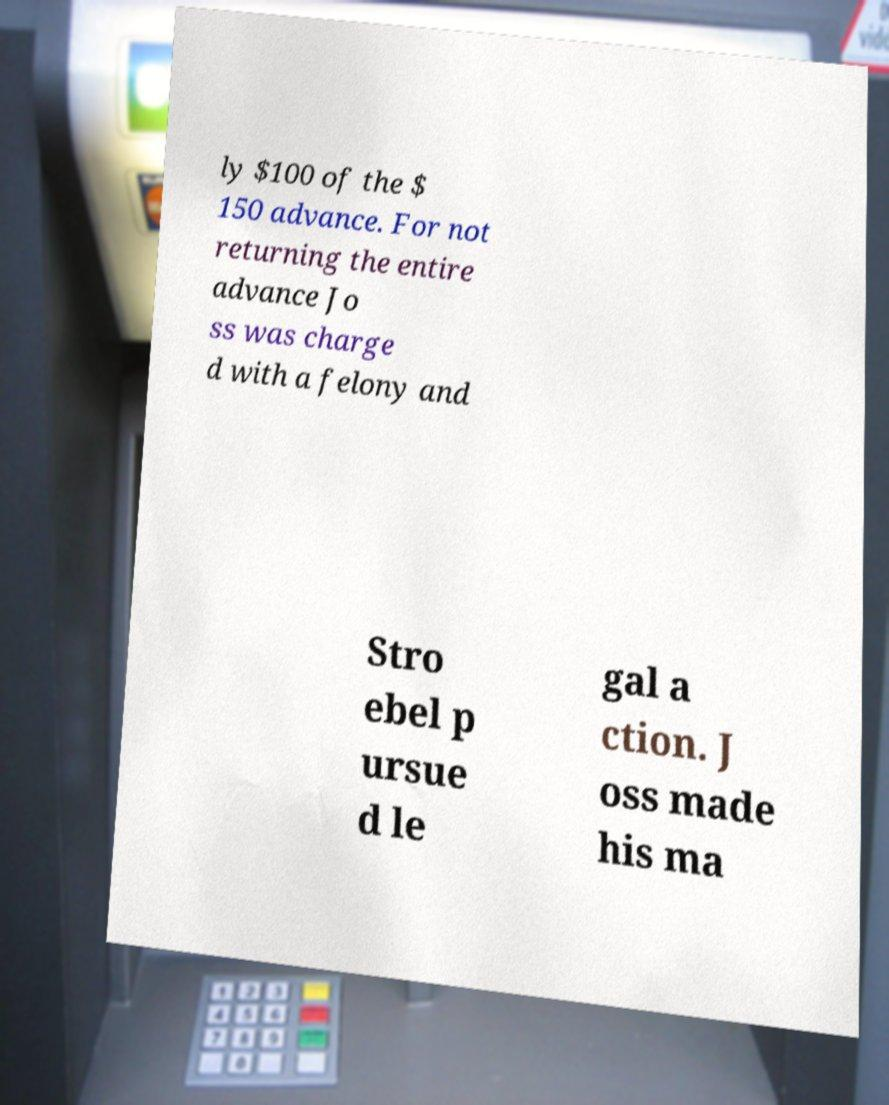Could you extract and type out the text from this image? ly $100 of the $ 150 advance. For not returning the entire advance Jo ss was charge d with a felony and Stro ebel p ursue d le gal a ction. J oss made his ma 